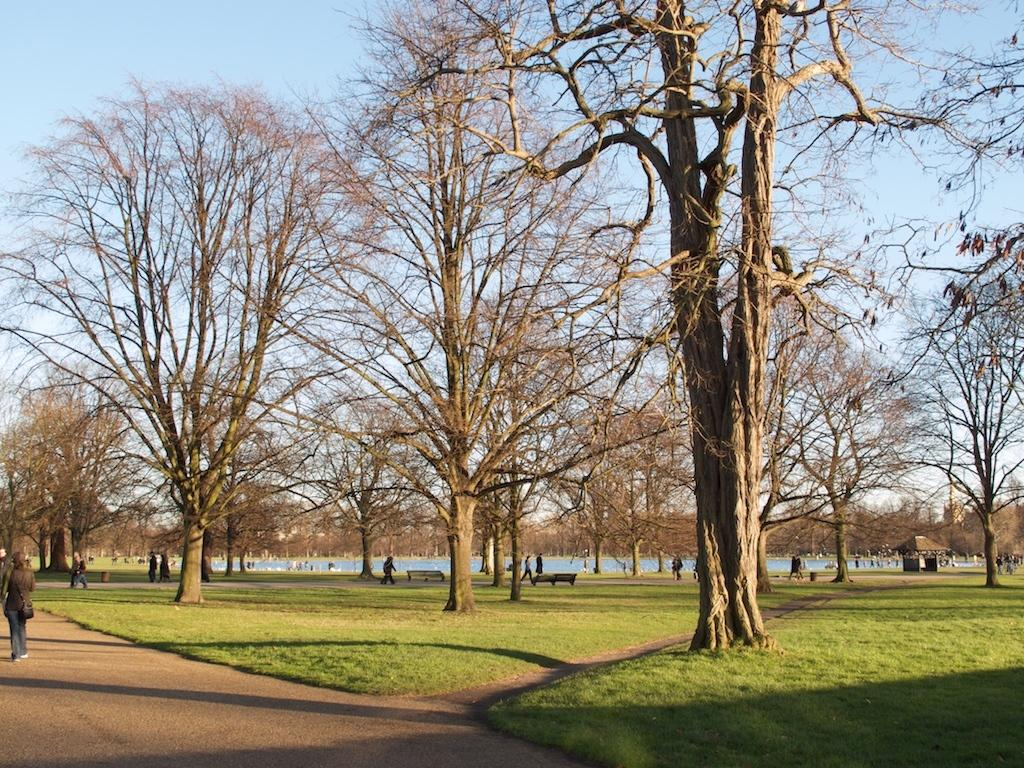What type of vegetation can be seen in the image? There is green grass in the image. What other natural elements are present in the image? There are trees in the image. What are the people in the image doing? The people are on a walkway in the image. What can be seen in the water in the image? The water is visible in the image, but it is not clear what is in it. What is visible in the sky in the image? Clouds are present in the sky in the image. What type of poison is being used by the people in the image? There is no indication of poison or any dangerous substances in the image; the people are simply walking on a walkway. What is the range of the whistle that can be heard in the image? There is no whistle present in the image, so it is not possible to determine its range. 